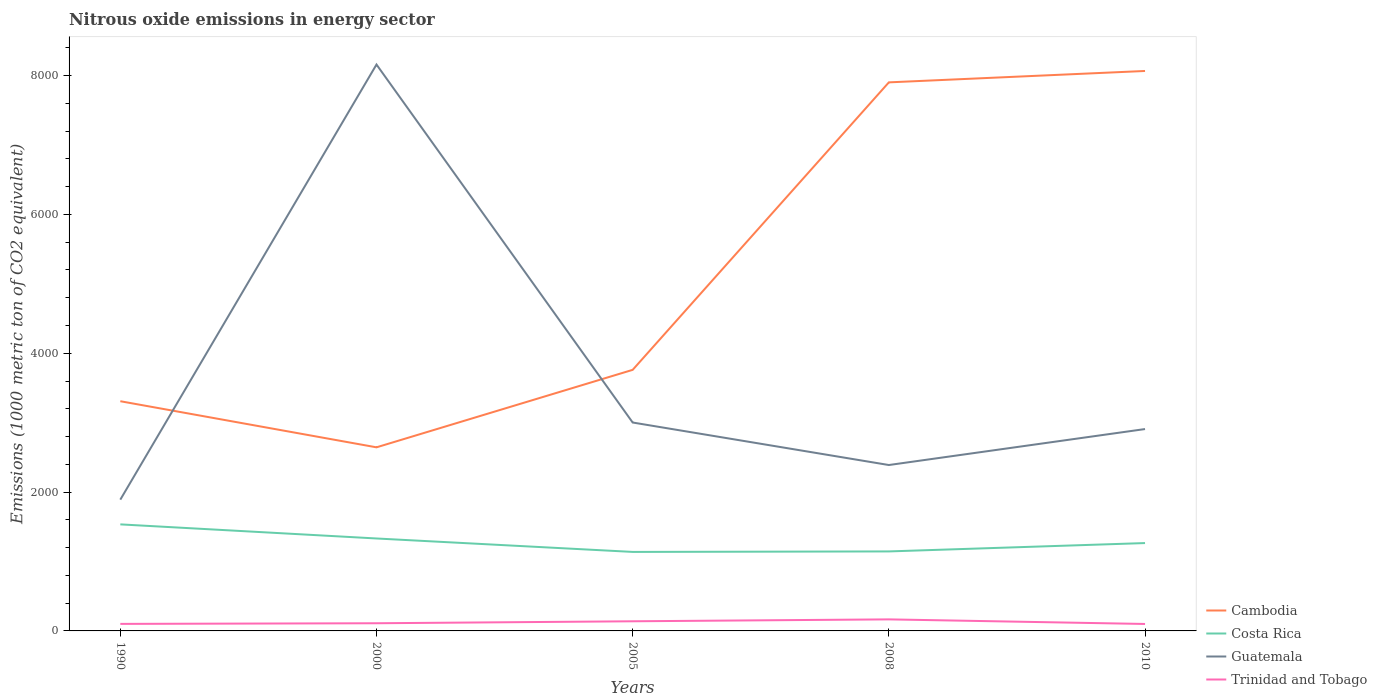Does the line corresponding to Cambodia intersect with the line corresponding to Guatemala?
Your response must be concise. Yes. Across all years, what is the maximum amount of nitrous oxide emitted in Cambodia?
Make the answer very short. 2644.9. In which year was the amount of nitrous oxide emitted in Guatemala maximum?
Provide a succinct answer. 1990. What is the total amount of nitrous oxide emitted in Guatemala in the graph?
Your response must be concise. 5251.3. What is the difference between the highest and the second highest amount of nitrous oxide emitted in Trinidad and Tobago?
Your answer should be compact. 66.2. Is the amount of nitrous oxide emitted in Trinidad and Tobago strictly greater than the amount of nitrous oxide emitted in Cambodia over the years?
Offer a very short reply. Yes. How many lines are there?
Give a very brief answer. 4. How many years are there in the graph?
Give a very brief answer. 5. Are the values on the major ticks of Y-axis written in scientific E-notation?
Offer a terse response. No. How many legend labels are there?
Your answer should be very brief. 4. How are the legend labels stacked?
Provide a succinct answer. Vertical. What is the title of the graph?
Offer a terse response. Nitrous oxide emissions in energy sector. What is the label or title of the Y-axis?
Keep it short and to the point. Emissions (1000 metric ton of CO2 equivalent). What is the Emissions (1000 metric ton of CO2 equivalent) in Cambodia in 1990?
Make the answer very short. 3309.2. What is the Emissions (1000 metric ton of CO2 equivalent) in Costa Rica in 1990?
Ensure brevity in your answer.  1535. What is the Emissions (1000 metric ton of CO2 equivalent) in Guatemala in 1990?
Ensure brevity in your answer.  1891.2. What is the Emissions (1000 metric ton of CO2 equivalent) in Trinidad and Tobago in 1990?
Offer a terse response. 101.3. What is the Emissions (1000 metric ton of CO2 equivalent) in Cambodia in 2000?
Ensure brevity in your answer.  2644.9. What is the Emissions (1000 metric ton of CO2 equivalent) of Costa Rica in 2000?
Offer a very short reply. 1331.8. What is the Emissions (1000 metric ton of CO2 equivalent) in Guatemala in 2000?
Offer a very short reply. 8159.4. What is the Emissions (1000 metric ton of CO2 equivalent) in Trinidad and Tobago in 2000?
Give a very brief answer. 110.5. What is the Emissions (1000 metric ton of CO2 equivalent) in Cambodia in 2005?
Your response must be concise. 3761.1. What is the Emissions (1000 metric ton of CO2 equivalent) in Costa Rica in 2005?
Offer a terse response. 1138.2. What is the Emissions (1000 metric ton of CO2 equivalent) of Guatemala in 2005?
Provide a short and direct response. 3002.4. What is the Emissions (1000 metric ton of CO2 equivalent) in Trinidad and Tobago in 2005?
Offer a terse response. 138.8. What is the Emissions (1000 metric ton of CO2 equivalent) of Cambodia in 2008?
Your answer should be compact. 7902.7. What is the Emissions (1000 metric ton of CO2 equivalent) in Costa Rica in 2008?
Your answer should be compact. 1145.2. What is the Emissions (1000 metric ton of CO2 equivalent) in Guatemala in 2008?
Provide a succinct answer. 2390. What is the Emissions (1000 metric ton of CO2 equivalent) of Trinidad and Tobago in 2008?
Ensure brevity in your answer.  166.3. What is the Emissions (1000 metric ton of CO2 equivalent) in Cambodia in 2010?
Keep it short and to the point. 8066.8. What is the Emissions (1000 metric ton of CO2 equivalent) in Costa Rica in 2010?
Your answer should be very brief. 1265.7. What is the Emissions (1000 metric ton of CO2 equivalent) of Guatemala in 2010?
Offer a terse response. 2908.1. What is the Emissions (1000 metric ton of CO2 equivalent) of Trinidad and Tobago in 2010?
Provide a succinct answer. 100.1. Across all years, what is the maximum Emissions (1000 metric ton of CO2 equivalent) of Cambodia?
Your answer should be very brief. 8066.8. Across all years, what is the maximum Emissions (1000 metric ton of CO2 equivalent) of Costa Rica?
Keep it short and to the point. 1535. Across all years, what is the maximum Emissions (1000 metric ton of CO2 equivalent) of Guatemala?
Offer a terse response. 8159.4. Across all years, what is the maximum Emissions (1000 metric ton of CO2 equivalent) in Trinidad and Tobago?
Your response must be concise. 166.3. Across all years, what is the minimum Emissions (1000 metric ton of CO2 equivalent) in Cambodia?
Offer a terse response. 2644.9. Across all years, what is the minimum Emissions (1000 metric ton of CO2 equivalent) in Costa Rica?
Offer a terse response. 1138.2. Across all years, what is the minimum Emissions (1000 metric ton of CO2 equivalent) in Guatemala?
Your answer should be very brief. 1891.2. Across all years, what is the minimum Emissions (1000 metric ton of CO2 equivalent) of Trinidad and Tobago?
Your response must be concise. 100.1. What is the total Emissions (1000 metric ton of CO2 equivalent) in Cambodia in the graph?
Make the answer very short. 2.57e+04. What is the total Emissions (1000 metric ton of CO2 equivalent) of Costa Rica in the graph?
Keep it short and to the point. 6415.9. What is the total Emissions (1000 metric ton of CO2 equivalent) of Guatemala in the graph?
Provide a succinct answer. 1.84e+04. What is the total Emissions (1000 metric ton of CO2 equivalent) in Trinidad and Tobago in the graph?
Keep it short and to the point. 617. What is the difference between the Emissions (1000 metric ton of CO2 equivalent) of Cambodia in 1990 and that in 2000?
Provide a short and direct response. 664.3. What is the difference between the Emissions (1000 metric ton of CO2 equivalent) in Costa Rica in 1990 and that in 2000?
Keep it short and to the point. 203.2. What is the difference between the Emissions (1000 metric ton of CO2 equivalent) of Guatemala in 1990 and that in 2000?
Provide a succinct answer. -6268.2. What is the difference between the Emissions (1000 metric ton of CO2 equivalent) in Cambodia in 1990 and that in 2005?
Your response must be concise. -451.9. What is the difference between the Emissions (1000 metric ton of CO2 equivalent) in Costa Rica in 1990 and that in 2005?
Offer a very short reply. 396.8. What is the difference between the Emissions (1000 metric ton of CO2 equivalent) in Guatemala in 1990 and that in 2005?
Your response must be concise. -1111.2. What is the difference between the Emissions (1000 metric ton of CO2 equivalent) in Trinidad and Tobago in 1990 and that in 2005?
Ensure brevity in your answer.  -37.5. What is the difference between the Emissions (1000 metric ton of CO2 equivalent) of Cambodia in 1990 and that in 2008?
Offer a terse response. -4593.5. What is the difference between the Emissions (1000 metric ton of CO2 equivalent) in Costa Rica in 1990 and that in 2008?
Keep it short and to the point. 389.8. What is the difference between the Emissions (1000 metric ton of CO2 equivalent) of Guatemala in 1990 and that in 2008?
Give a very brief answer. -498.8. What is the difference between the Emissions (1000 metric ton of CO2 equivalent) of Trinidad and Tobago in 1990 and that in 2008?
Keep it short and to the point. -65. What is the difference between the Emissions (1000 metric ton of CO2 equivalent) in Cambodia in 1990 and that in 2010?
Offer a terse response. -4757.6. What is the difference between the Emissions (1000 metric ton of CO2 equivalent) of Costa Rica in 1990 and that in 2010?
Keep it short and to the point. 269.3. What is the difference between the Emissions (1000 metric ton of CO2 equivalent) in Guatemala in 1990 and that in 2010?
Ensure brevity in your answer.  -1016.9. What is the difference between the Emissions (1000 metric ton of CO2 equivalent) of Cambodia in 2000 and that in 2005?
Provide a short and direct response. -1116.2. What is the difference between the Emissions (1000 metric ton of CO2 equivalent) of Costa Rica in 2000 and that in 2005?
Offer a terse response. 193.6. What is the difference between the Emissions (1000 metric ton of CO2 equivalent) in Guatemala in 2000 and that in 2005?
Provide a short and direct response. 5157. What is the difference between the Emissions (1000 metric ton of CO2 equivalent) in Trinidad and Tobago in 2000 and that in 2005?
Make the answer very short. -28.3. What is the difference between the Emissions (1000 metric ton of CO2 equivalent) in Cambodia in 2000 and that in 2008?
Offer a very short reply. -5257.8. What is the difference between the Emissions (1000 metric ton of CO2 equivalent) of Costa Rica in 2000 and that in 2008?
Your response must be concise. 186.6. What is the difference between the Emissions (1000 metric ton of CO2 equivalent) of Guatemala in 2000 and that in 2008?
Offer a terse response. 5769.4. What is the difference between the Emissions (1000 metric ton of CO2 equivalent) of Trinidad and Tobago in 2000 and that in 2008?
Your response must be concise. -55.8. What is the difference between the Emissions (1000 metric ton of CO2 equivalent) in Cambodia in 2000 and that in 2010?
Your response must be concise. -5421.9. What is the difference between the Emissions (1000 metric ton of CO2 equivalent) of Costa Rica in 2000 and that in 2010?
Your answer should be very brief. 66.1. What is the difference between the Emissions (1000 metric ton of CO2 equivalent) in Guatemala in 2000 and that in 2010?
Your answer should be very brief. 5251.3. What is the difference between the Emissions (1000 metric ton of CO2 equivalent) in Trinidad and Tobago in 2000 and that in 2010?
Keep it short and to the point. 10.4. What is the difference between the Emissions (1000 metric ton of CO2 equivalent) in Cambodia in 2005 and that in 2008?
Ensure brevity in your answer.  -4141.6. What is the difference between the Emissions (1000 metric ton of CO2 equivalent) of Costa Rica in 2005 and that in 2008?
Ensure brevity in your answer.  -7. What is the difference between the Emissions (1000 metric ton of CO2 equivalent) in Guatemala in 2005 and that in 2008?
Your answer should be very brief. 612.4. What is the difference between the Emissions (1000 metric ton of CO2 equivalent) in Trinidad and Tobago in 2005 and that in 2008?
Your response must be concise. -27.5. What is the difference between the Emissions (1000 metric ton of CO2 equivalent) in Cambodia in 2005 and that in 2010?
Provide a short and direct response. -4305.7. What is the difference between the Emissions (1000 metric ton of CO2 equivalent) of Costa Rica in 2005 and that in 2010?
Your answer should be very brief. -127.5. What is the difference between the Emissions (1000 metric ton of CO2 equivalent) of Guatemala in 2005 and that in 2010?
Provide a short and direct response. 94.3. What is the difference between the Emissions (1000 metric ton of CO2 equivalent) in Trinidad and Tobago in 2005 and that in 2010?
Your answer should be very brief. 38.7. What is the difference between the Emissions (1000 metric ton of CO2 equivalent) of Cambodia in 2008 and that in 2010?
Your answer should be very brief. -164.1. What is the difference between the Emissions (1000 metric ton of CO2 equivalent) in Costa Rica in 2008 and that in 2010?
Keep it short and to the point. -120.5. What is the difference between the Emissions (1000 metric ton of CO2 equivalent) of Guatemala in 2008 and that in 2010?
Offer a very short reply. -518.1. What is the difference between the Emissions (1000 metric ton of CO2 equivalent) of Trinidad and Tobago in 2008 and that in 2010?
Provide a short and direct response. 66.2. What is the difference between the Emissions (1000 metric ton of CO2 equivalent) in Cambodia in 1990 and the Emissions (1000 metric ton of CO2 equivalent) in Costa Rica in 2000?
Provide a succinct answer. 1977.4. What is the difference between the Emissions (1000 metric ton of CO2 equivalent) of Cambodia in 1990 and the Emissions (1000 metric ton of CO2 equivalent) of Guatemala in 2000?
Offer a terse response. -4850.2. What is the difference between the Emissions (1000 metric ton of CO2 equivalent) of Cambodia in 1990 and the Emissions (1000 metric ton of CO2 equivalent) of Trinidad and Tobago in 2000?
Offer a terse response. 3198.7. What is the difference between the Emissions (1000 metric ton of CO2 equivalent) in Costa Rica in 1990 and the Emissions (1000 metric ton of CO2 equivalent) in Guatemala in 2000?
Provide a succinct answer. -6624.4. What is the difference between the Emissions (1000 metric ton of CO2 equivalent) in Costa Rica in 1990 and the Emissions (1000 metric ton of CO2 equivalent) in Trinidad and Tobago in 2000?
Keep it short and to the point. 1424.5. What is the difference between the Emissions (1000 metric ton of CO2 equivalent) in Guatemala in 1990 and the Emissions (1000 metric ton of CO2 equivalent) in Trinidad and Tobago in 2000?
Your answer should be compact. 1780.7. What is the difference between the Emissions (1000 metric ton of CO2 equivalent) in Cambodia in 1990 and the Emissions (1000 metric ton of CO2 equivalent) in Costa Rica in 2005?
Ensure brevity in your answer.  2171. What is the difference between the Emissions (1000 metric ton of CO2 equivalent) of Cambodia in 1990 and the Emissions (1000 metric ton of CO2 equivalent) of Guatemala in 2005?
Offer a very short reply. 306.8. What is the difference between the Emissions (1000 metric ton of CO2 equivalent) in Cambodia in 1990 and the Emissions (1000 metric ton of CO2 equivalent) in Trinidad and Tobago in 2005?
Provide a short and direct response. 3170.4. What is the difference between the Emissions (1000 metric ton of CO2 equivalent) in Costa Rica in 1990 and the Emissions (1000 metric ton of CO2 equivalent) in Guatemala in 2005?
Your answer should be compact. -1467.4. What is the difference between the Emissions (1000 metric ton of CO2 equivalent) of Costa Rica in 1990 and the Emissions (1000 metric ton of CO2 equivalent) of Trinidad and Tobago in 2005?
Your answer should be compact. 1396.2. What is the difference between the Emissions (1000 metric ton of CO2 equivalent) in Guatemala in 1990 and the Emissions (1000 metric ton of CO2 equivalent) in Trinidad and Tobago in 2005?
Ensure brevity in your answer.  1752.4. What is the difference between the Emissions (1000 metric ton of CO2 equivalent) in Cambodia in 1990 and the Emissions (1000 metric ton of CO2 equivalent) in Costa Rica in 2008?
Your response must be concise. 2164. What is the difference between the Emissions (1000 metric ton of CO2 equivalent) of Cambodia in 1990 and the Emissions (1000 metric ton of CO2 equivalent) of Guatemala in 2008?
Provide a succinct answer. 919.2. What is the difference between the Emissions (1000 metric ton of CO2 equivalent) in Cambodia in 1990 and the Emissions (1000 metric ton of CO2 equivalent) in Trinidad and Tobago in 2008?
Offer a very short reply. 3142.9. What is the difference between the Emissions (1000 metric ton of CO2 equivalent) of Costa Rica in 1990 and the Emissions (1000 metric ton of CO2 equivalent) of Guatemala in 2008?
Keep it short and to the point. -855. What is the difference between the Emissions (1000 metric ton of CO2 equivalent) in Costa Rica in 1990 and the Emissions (1000 metric ton of CO2 equivalent) in Trinidad and Tobago in 2008?
Offer a very short reply. 1368.7. What is the difference between the Emissions (1000 metric ton of CO2 equivalent) of Guatemala in 1990 and the Emissions (1000 metric ton of CO2 equivalent) of Trinidad and Tobago in 2008?
Make the answer very short. 1724.9. What is the difference between the Emissions (1000 metric ton of CO2 equivalent) in Cambodia in 1990 and the Emissions (1000 metric ton of CO2 equivalent) in Costa Rica in 2010?
Provide a succinct answer. 2043.5. What is the difference between the Emissions (1000 metric ton of CO2 equivalent) of Cambodia in 1990 and the Emissions (1000 metric ton of CO2 equivalent) of Guatemala in 2010?
Offer a terse response. 401.1. What is the difference between the Emissions (1000 metric ton of CO2 equivalent) in Cambodia in 1990 and the Emissions (1000 metric ton of CO2 equivalent) in Trinidad and Tobago in 2010?
Give a very brief answer. 3209.1. What is the difference between the Emissions (1000 metric ton of CO2 equivalent) of Costa Rica in 1990 and the Emissions (1000 metric ton of CO2 equivalent) of Guatemala in 2010?
Keep it short and to the point. -1373.1. What is the difference between the Emissions (1000 metric ton of CO2 equivalent) in Costa Rica in 1990 and the Emissions (1000 metric ton of CO2 equivalent) in Trinidad and Tobago in 2010?
Provide a succinct answer. 1434.9. What is the difference between the Emissions (1000 metric ton of CO2 equivalent) of Guatemala in 1990 and the Emissions (1000 metric ton of CO2 equivalent) of Trinidad and Tobago in 2010?
Offer a terse response. 1791.1. What is the difference between the Emissions (1000 metric ton of CO2 equivalent) of Cambodia in 2000 and the Emissions (1000 metric ton of CO2 equivalent) of Costa Rica in 2005?
Give a very brief answer. 1506.7. What is the difference between the Emissions (1000 metric ton of CO2 equivalent) in Cambodia in 2000 and the Emissions (1000 metric ton of CO2 equivalent) in Guatemala in 2005?
Make the answer very short. -357.5. What is the difference between the Emissions (1000 metric ton of CO2 equivalent) of Cambodia in 2000 and the Emissions (1000 metric ton of CO2 equivalent) of Trinidad and Tobago in 2005?
Your response must be concise. 2506.1. What is the difference between the Emissions (1000 metric ton of CO2 equivalent) of Costa Rica in 2000 and the Emissions (1000 metric ton of CO2 equivalent) of Guatemala in 2005?
Offer a very short reply. -1670.6. What is the difference between the Emissions (1000 metric ton of CO2 equivalent) of Costa Rica in 2000 and the Emissions (1000 metric ton of CO2 equivalent) of Trinidad and Tobago in 2005?
Your answer should be very brief. 1193. What is the difference between the Emissions (1000 metric ton of CO2 equivalent) in Guatemala in 2000 and the Emissions (1000 metric ton of CO2 equivalent) in Trinidad and Tobago in 2005?
Keep it short and to the point. 8020.6. What is the difference between the Emissions (1000 metric ton of CO2 equivalent) of Cambodia in 2000 and the Emissions (1000 metric ton of CO2 equivalent) of Costa Rica in 2008?
Offer a terse response. 1499.7. What is the difference between the Emissions (1000 metric ton of CO2 equivalent) of Cambodia in 2000 and the Emissions (1000 metric ton of CO2 equivalent) of Guatemala in 2008?
Offer a very short reply. 254.9. What is the difference between the Emissions (1000 metric ton of CO2 equivalent) in Cambodia in 2000 and the Emissions (1000 metric ton of CO2 equivalent) in Trinidad and Tobago in 2008?
Offer a terse response. 2478.6. What is the difference between the Emissions (1000 metric ton of CO2 equivalent) of Costa Rica in 2000 and the Emissions (1000 metric ton of CO2 equivalent) of Guatemala in 2008?
Your answer should be compact. -1058.2. What is the difference between the Emissions (1000 metric ton of CO2 equivalent) in Costa Rica in 2000 and the Emissions (1000 metric ton of CO2 equivalent) in Trinidad and Tobago in 2008?
Give a very brief answer. 1165.5. What is the difference between the Emissions (1000 metric ton of CO2 equivalent) in Guatemala in 2000 and the Emissions (1000 metric ton of CO2 equivalent) in Trinidad and Tobago in 2008?
Your response must be concise. 7993.1. What is the difference between the Emissions (1000 metric ton of CO2 equivalent) in Cambodia in 2000 and the Emissions (1000 metric ton of CO2 equivalent) in Costa Rica in 2010?
Your answer should be very brief. 1379.2. What is the difference between the Emissions (1000 metric ton of CO2 equivalent) in Cambodia in 2000 and the Emissions (1000 metric ton of CO2 equivalent) in Guatemala in 2010?
Make the answer very short. -263.2. What is the difference between the Emissions (1000 metric ton of CO2 equivalent) in Cambodia in 2000 and the Emissions (1000 metric ton of CO2 equivalent) in Trinidad and Tobago in 2010?
Offer a very short reply. 2544.8. What is the difference between the Emissions (1000 metric ton of CO2 equivalent) of Costa Rica in 2000 and the Emissions (1000 metric ton of CO2 equivalent) of Guatemala in 2010?
Offer a terse response. -1576.3. What is the difference between the Emissions (1000 metric ton of CO2 equivalent) of Costa Rica in 2000 and the Emissions (1000 metric ton of CO2 equivalent) of Trinidad and Tobago in 2010?
Your answer should be very brief. 1231.7. What is the difference between the Emissions (1000 metric ton of CO2 equivalent) in Guatemala in 2000 and the Emissions (1000 metric ton of CO2 equivalent) in Trinidad and Tobago in 2010?
Provide a succinct answer. 8059.3. What is the difference between the Emissions (1000 metric ton of CO2 equivalent) of Cambodia in 2005 and the Emissions (1000 metric ton of CO2 equivalent) of Costa Rica in 2008?
Make the answer very short. 2615.9. What is the difference between the Emissions (1000 metric ton of CO2 equivalent) of Cambodia in 2005 and the Emissions (1000 metric ton of CO2 equivalent) of Guatemala in 2008?
Make the answer very short. 1371.1. What is the difference between the Emissions (1000 metric ton of CO2 equivalent) in Cambodia in 2005 and the Emissions (1000 metric ton of CO2 equivalent) in Trinidad and Tobago in 2008?
Give a very brief answer. 3594.8. What is the difference between the Emissions (1000 metric ton of CO2 equivalent) of Costa Rica in 2005 and the Emissions (1000 metric ton of CO2 equivalent) of Guatemala in 2008?
Make the answer very short. -1251.8. What is the difference between the Emissions (1000 metric ton of CO2 equivalent) in Costa Rica in 2005 and the Emissions (1000 metric ton of CO2 equivalent) in Trinidad and Tobago in 2008?
Offer a terse response. 971.9. What is the difference between the Emissions (1000 metric ton of CO2 equivalent) in Guatemala in 2005 and the Emissions (1000 metric ton of CO2 equivalent) in Trinidad and Tobago in 2008?
Provide a short and direct response. 2836.1. What is the difference between the Emissions (1000 metric ton of CO2 equivalent) in Cambodia in 2005 and the Emissions (1000 metric ton of CO2 equivalent) in Costa Rica in 2010?
Provide a succinct answer. 2495.4. What is the difference between the Emissions (1000 metric ton of CO2 equivalent) in Cambodia in 2005 and the Emissions (1000 metric ton of CO2 equivalent) in Guatemala in 2010?
Offer a terse response. 853. What is the difference between the Emissions (1000 metric ton of CO2 equivalent) of Cambodia in 2005 and the Emissions (1000 metric ton of CO2 equivalent) of Trinidad and Tobago in 2010?
Provide a succinct answer. 3661. What is the difference between the Emissions (1000 metric ton of CO2 equivalent) of Costa Rica in 2005 and the Emissions (1000 metric ton of CO2 equivalent) of Guatemala in 2010?
Give a very brief answer. -1769.9. What is the difference between the Emissions (1000 metric ton of CO2 equivalent) in Costa Rica in 2005 and the Emissions (1000 metric ton of CO2 equivalent) in Trinidad and Tobago in 2010?
Your answer should be very brief. 1038.1. What is the difference between the Emissions (1000 metric ton of CO2 equivalent) in Guatemala in 2005 and the Emissions (1000 metric ton of CO2 equivalent) in Trinidad and Tobago in 2010?
Give a very brief answer. 2902.3. What is the difference between the Emissions (1000 metric ton of CO2 equivalent) of Cambodia in 2008 and the Emissions (1000 metric ton of CO2 equivalent) of Costa Rica in 2010?
Ensure brevity in your answer.  6637. What is the difference between the Emissions (1000 metric ton of CO2 equivalent) in Cambodia in 2008 and the Emissions (1000 metric ton of CO2 equivalent) in Guatemala in 2010?
Give a very brief answer. 4994.6. What is the difference between the Emissions (1000 metric ton of CO2 equivalent) in Cambodia in 2008 and the Emissions (1000 metric ton of CO2 equivalent) in Trinidad and Tobago in 2010?
Offer a very short reply. 7802.6. What is the difference between the Emissions (1000 metric ton of CO2 equivalent) of Costa Rica in 2008 and the Emissions (1000 metric ton of CO2 equivalent) of Guatemala in 2010?
Ensure brevity in your answer.  -1762.9. What is the difference between the Emissions (1000 metric ton of CO2 equivalent) of Costa Rica in 2008 and the Emissions (1000 metric ton of CO2 equivalent) of Trinidad and Tobago in 2010?
Give a very brief answer. 1045.1. What is the difference between the Emissions (1000 metric ton of CO2 equivalent) of Guatemala in 2008 and the Emissions (1000 metric ton of CO2 equivalent) of Trinidad and Tobago in 2010?
Provide a short and direct response. 2289.9. What is the average Emissions (1000 metric ton of CO2 equivalent) of Cambodia per year?
Your response must be concise. 5136.94. What is the average Emissions (1000 metric ton of CO2 equivalent) in Costa Rica per year?
Offer a terse response. 1283.18. What is the average Emissions (1000 metric ton of CO2 equivalent) of Guatemala per year?
Your answer should be compact. 3670.22. What is the average Emissions (1000 metric ton of CO2 equivalent) in Trinidad and Tobago per year?
Make the answer very short. 123.4. In the year 1990, what is the difference between the Emissions (1000 metric ton of CO2 equivalent) in Cambodia and Emissions (1000 metric ton of CO2 equivalent) in Costa Rica?
Offer a terse response. 1774.2. In the year 1990, what is the difference between the Emissions (1000 metric ton of CO2 equivalent) of Cambodia and Emissions (1000 metric ton of CO2 equivalent) of Guatemala?
Offer a very short reply. 1418. In the year 1990, what is the difference between the Emissions (1000 metric ton of CO2 equivalent) of Cambodia and Emissions (1000 metric ton of CO2 equivalent) of Trinidad and Tobago?
Keep it short and to the point. 3207.9. In the year 1990, what is the difference between the Emissions (1000 metric ton of CO2 equivalent) in Costa Rica and Emissions (1000 metric ton of CO2 equivalent) in Guatemala?
Offer a very short reply. -356.2. In the year 1990, what is the difference between the Emissions (1000 metric ton of CO2 equivalent) in Costa Rica and Emissions (1000 metric ton of CO2 equivalent) in Trinidad and Tobago?
Your answer should be very brief. 1433.7. In the year 1990, what is the difference between the Emissions (1000 metric ton of CO2 equivalent) in Guatemala and Emissions (1000 metric ton of CO2 equivalent) in Trinidad and Tobago?
Give a very brief answer. 1789.9. In the year 2000, what is the difference between the Emissions (1000 metric ton of CO2 equivalent) of Cambodia and Emissions (1000 metric ton of CO2 equivalent) of Costa Rica?
Your answer should be compact. 1313.1. In the year 2000, what is the difference between the Emissions (1000 metric ton of CO2 equivalent) of Cambodia and Emissions (1000 metric ton of CO2 equivalent) of Guatemala?
Ensure brevity in your answer.  -5514.5. In the year 2000, what is the difference between the Emissions (1000 metric ton of CO2 equivalent) of Cambodia and Emissions (1000 metric ton of CO2 equivalent) of Trinidad and Tobago?
Provide a succinct answer. 2534.4. In the year 2000, what is the difference between the Emissions (1000 metric ton of CO2 equivalent) in Costa Rica and Emissions (1000 metric ton of CO2 equivalent) in Guatemala?
Make the answer very short. -6827.6. In the year 2000, what is the difference between the Emissions (1000 metric ton of CO2 equivalent) in Costa Rica and Emissions (1000 metric ton of CO2 equivalent) in Trinidad and Tobago?
Your answer should be compact. 1221.3. In the year 2000, what is the difference between the Emissions (1000 metric ton of CO2 equivalent) in Guatemala and Emissions (1000 metric ton of CO2 equivalent) in Trinidad and Tobago?
Give a very brief answer. 8048.9. In the year 2005, what is the difference between the Emissions (1000 metric ton of CO2 equivalent) in Cambodia and Emissions (1000 metric ton of CO2 equivalent) in Costa Rica?
Your response must be concise. 2622.9. In the year 2005, what is the difference between the Emissions (1000 metric ton of CO2 equivalent) in Cambodia and Emissions (1000 metric ton of CO2 equivalent) in Guatemala?
Your answer should be very brief. 758.7. In the year 2005, what is the difference between the Emissions (1000 metric ton of CO2 equivalent) in Cambodia and Emissions (1000 metric ton of CO2 equivalent) in Trinidad and Tobago?
Your answer should be compact. 3622.3. In the year 2005, what is the difference between the Emissions (1000 metric ton of CO2 equivalent) in Costa Rica and Emissions (1000 metric ton of CO2 equivalent) in Guatemala?
Your response must be concise. -1864.2. In the year 2005, what is the difference between the Emissions (1000 metric ton of CO2 equivalent) in Costa Rica and Emissions (1000 metric ton of CO2 equivalent) in Trinidad and Tobago?
Your answer should be very brief. 999.4. In the year 2005, what is the difference between the Emissions (1000 metric ton of CO2 equivalent) of Guatemala and Emissions (1000 metric ton of CO2 equivalent) of Trinidad and Tobago?
Offer a terse response. 2863.6. In the year 2008, what is the difference between the Emissions (1000 metric ton of CO2 equivalent) in Cambodia and Emissions (1000 metric ton of CO2 equivalent) in Costa Rica?
Offer a terse response. 6757.5. In the year 2008, what is the difference between the Emissions (1000 metric ton of CO2 equivalent) in Cambodia and Emissions (1000 metric ton of CO2 equivalent) in Guatemala?
Offer a very short reply. 5512.7. In the year 2008, what is the difference between the Emissions (1000 metric ton of CO2 equivalent) of Cambodia and Emissions (1000 metric ton of CO2 equivalent) of Trinidad and Tobago?
Ensure brevity in your answer.  7736.4. In the year 2008, what is the difference between the Emissions (1000 metric ton of CO2 equivalent) of Costa Rica and Emissions (1000 metric ton of CO2 equivalent) of Guatemala?
Provide a succinct answer. -1244.8. In the year 2008, what is the difference between the Emissions (1000 metric ton of CO2 equivalent) of Costa Rica and Emissions (1000 metric ton of CO2 equivalent) of Trinidad and Tobago?
Offer a terse response. 978.9. In the year 2008, what is the difference between the Emissions (1000 metric ton of CO2 equivalent) of Guatemala and Emissions (1000 metric ton of CO2 equivalent) of Trinidad and Tobago?
Your response must be concise. 2223.7. In the year 2010, what is the difference between the Emissions (1000 metric ton of CO2 equivalent) of Cambodia and Emissions (1000 metric ton of CO2 equivalent) of Costa Rica?
Ensure brevity in your answer.  6801.1. In the year 2010, what is the difference between the Emissions (1000 metric ton of CO2 equivalent) in Cambodia and Emissions (1000 metric ton of CO2 equivalent) in Guatemala?
Your response must be concise. 5158.7. In the year 2010, what is the difference between the Emissions (1000 metric ton of CO2 equivalent) in Cambodia and Emissions (1000 metric ton of CO2 equivalent) in Trinidad and Tobago?
Your answer should be compact. 7966.7. In the year 2010, what is the difference between the Emissions (1000 metric ton of CO2 equivalent) in Costa Rica and Emissions (1000 metric ton of CO2 equivalent) in Guatemala?
Offer a very short reply. -1642.4. In the year 2010, what is the difference between the Emissions (1000 metric ton of CO2 equivalent) of Costa Rica and Emissions (1000 metric ton of CO2 equivalent) of Trinidad and Tobago?
Give a very brief answer. 1165.6. In the year 2010, what is the difference between the Emissions (1000 metric ton of CO2 equivalent) of Guatemala and Emissions (1000 metric ton of CO2 equivalent) of Trinidad and Tobago?
Your answer should be compact. 2808. What is the ratio of the Emissions (1000 metric ton of CO2 equivalent) in Cambodia in 1990 to that in 2000?
Give a very brief answer. 1.25. What is the ratio of the Emissions (1000 metric ton of CO2 equivalent) in Costa Rica in 1990 to that in 2000?
Your answer should be very brief. 1.15. What is the ratio of the Emissions (1000 metric ton of CO2 equivalent) of Guatemala in 1990 to that in 2000?
Provide a short and direct response. 0.23. What is the ratio of the Emissions (1000 metric ton of CO2 equivalent) of Trinidad and Tobago in 1990 to that in 2000?
Provide a succinct answer. 0.92. What is the ratio of the Emissions (1000 metric ton of CO2 equivalent) of Cambodia in 1990 to that in 2005?
Your answer should be very brief. 0.88. What is the ratio of the Emissions (1000 metric ton of CO2 equivalent) in Costa Rica in 1990 to that in 2005?
Keep it short and to the point. 1.35. What is the ratio of the Emissions (1000 metric ton of CO2 equivalent) in Guatemala in 1990 to that in 2005?
Your answer should be very brief. 0.63. What is the ratio of the Emissions (1000 metric ton of CO2 equivalent) of Trinidad and Tobago in 1990 to that in 2005?
Provide a succinct answer. 0.73. What is the ratio of the Emissions (1000 metric ton of CO2 equivalent) in Cambodia in 1990 to that in 2008?
Keep it short and to the point. 0.42. What is the ratio of the Emissions (1000 metric ton of CO2 equivalent) of Costa Rica in 1990 to that in 2008?
Make the answer very short. 1.34. What is the ratio of the Emissions (1000 metric ton of CO2 equivalent) in Guatemala in 1990 to that in 2008?
Make the answer very short. 0.79. What is the ratio of the Emissions (1000 metric ton of CO2 equivalent) of Trinidad and Tobago in 1990 to that in 2008?
Give a very brief answer. 0.61. What is the ratio of the Emissions (1000 metric ton of CO2 equivalent) in Cambodia in 1990 to that in 2010?
Provide a short and direct response. 0.41. What is the ratio of the Emissions (1000 metric ton of CO2 equivalent) of Costa Rica in 1990 to that in 2010?
Ensure brevity in your answer.  1.21. What is the ratio of the Emissions (1000 metric ton of CO2 equivalent) in Guatemala in 1990 to that in 2010?
Your answer should be compact. 0.65. What is the ratio of the Emissions (1000 metric ton of CO2 equivalent) in Cambodia in 2000 to that in 2005?
Your answer should be compact. 0.7. What is the ratio of the Emissions (1000 metric ton of CO2 equivalent) of Costa Rica in 2000 to that in 2005?
Make the answer very short. 1.17. What is the ratio of the Emissions (1000 metric ton of CO2 equivalent) in Guatemala in 2000 to that in 2005?
Offer a terse response. 2.72. What is the ratio of the Emissions (1000 metric ton of CO2 equivalent) in Trinidad and Tobago in 2000 to that in 2005?
Provide a short and direct response. 0.8. What is the ratio of the Emissions (1000 metric ton of CO2 equivalent) in Cambodia in 2000 to that in 2008?
Your answer should be very brief. 0.33. What is the ratio of the Emissions (1000 metric ton of CO2 equivalent) in Costa Rica in 2000 to that in 2008?
Offer a terse response. 1.16. What is the ratio of the Emissions (1000 metric ton of CO2 equivalent) of Guatemala in 2000 to that in 2008?
Your answer should be compact. 3.41. What is the ratio of the Emissions (1000 metric ton of CO2 equivalent) in Trinidad and Tobago in 2000 to that in 2008?
Your answer should be very brief. 0.66. What is the ratio of the Emissions (1000 metric ton of CO2 equivalent) of Cambodia in 2000 to that in 2010?
Give a very brief answer. 0.33. What is the ratio of the Emissions (1000 metric ton of CO2 equivalent) of Costa Rica in 2000 to that in 2010?
Keep it short and to the point. 1.05. What is the ratio of the Emissions (1000 metric ton of CO2 equivalent) in Guatemala in 2000 to that in 2010?
Provide a short and direct response. 2.81. What is the ratio of the Emissions (1000 metric ton of CO2 equivalent) of Trinidad and Tobago in 2000 to that in 2010?
Offer a terse response. 1.1. What is the ratio of the Emissions (1000 metric ton of CO2 equivalent) in Cambodia in 2005 to that in 2008?
Offer a very short reply. 0.48. What is the ratio of the Emissions (1000 metric ton of CO2 equivalent) of Costa Rica in 2005 to that in 2008?
Make the answer very short. 0.99. What is the ratio of the Emissions (1000 metric ton of CO2 equivalent) in Guatemala in 2005 to that in 2008?
Ensure brevity in your answer.  1.26. What is the ratio of the Emissions (1000 metric ton of CO2 equivalent) in Trinidad and Tobago in 2005 to that in 2008?
Keep it short and to the point. 0.83. What is the ratio of the Emissions (1000 metric ton of CO2 equivalent) in Cambodia in 2005 to that in 2010?
Provide a short and direct response. 0.47. What is the ratio of the Emissions (1000 metric ton of CO2 equivalent) in Costa Rica in 2005 to that in 2010?
Offer a very short reply. 0.9. What is the ratio of the Emissions (1000 metric ton of CO2 equivalent) of Guatemala in 2005 to that in 2010?
Give a very brief answer. 1.03. What is the ratio of the Emissions (1000 metric ton of CO2 equivalent) of Trinidad and Tobago in 2005 to that in 2010?
Provide a succinct answer. 1.39. What is the ratio of the Emissions (1000 metric ton of CO2 equivalent) of Cambodia in 2008 to that in 2010?
Provide a succinct answer. 0.98. What is the ratio of the Emissions (1000 metric ton of CO2 equivalent) in Costa Rica in 2008 to that in 2010?
Provide a succinct answer. 0.9. What is the ratio of the Emissions (1000 metric ton of CO2 equivalent) in Guatemala in 2008 to that in 2010?
Keep it short and to the point. 0.82. What is the ratio of the Emissions (1000 metric ton of CO2 equivalent) in Trinidad and Tobago in 2008 to that in 2010?
Make the answer very short. 1.66. What is the difference between the highest and the second highest Emissions (1000 metric ton of CO2 equivalent) in Cambodia?
Keep it short and to the point. 164.1. What is the difference between the highest and the second highest Emissions (1000 metric ton of CO2 equivalent) of Costa Rica?
Make the answer very short. 203.2. What is the difference between the highest and the second highest Emissions (1000 metric ton of CO2 equivalent) in Guatemala?
Provide a succinct answer. 5157. What is the difference between the highest and the second highest Emissions (1000 metric ton of CO2 equivalent) in Trinidad and Tobago?
Your answer should be very brief. 27.5. What is the difference between the highest and the lowest Emissions (1000 metric ton of CO2 equivalent) of Cambodia?
Give a very brief answer. 5421.9. What is the difference between the highest and the lowest Emissions (1000 metric ton of CO2 equivalent) in Costa Rica?
Offer a very short reply. 396.8. What is the difference between the highest and the lowest Emissions (1000 metric ton of CO2 equivalent) of Guatemala?
Make the answer very short. 6268.2. What is the difference between the highest and the lowest Emissions (1000 metric ton of CO2 equivalent) in Trinidad and Tobago?
Your response must be concise. 66.2. 